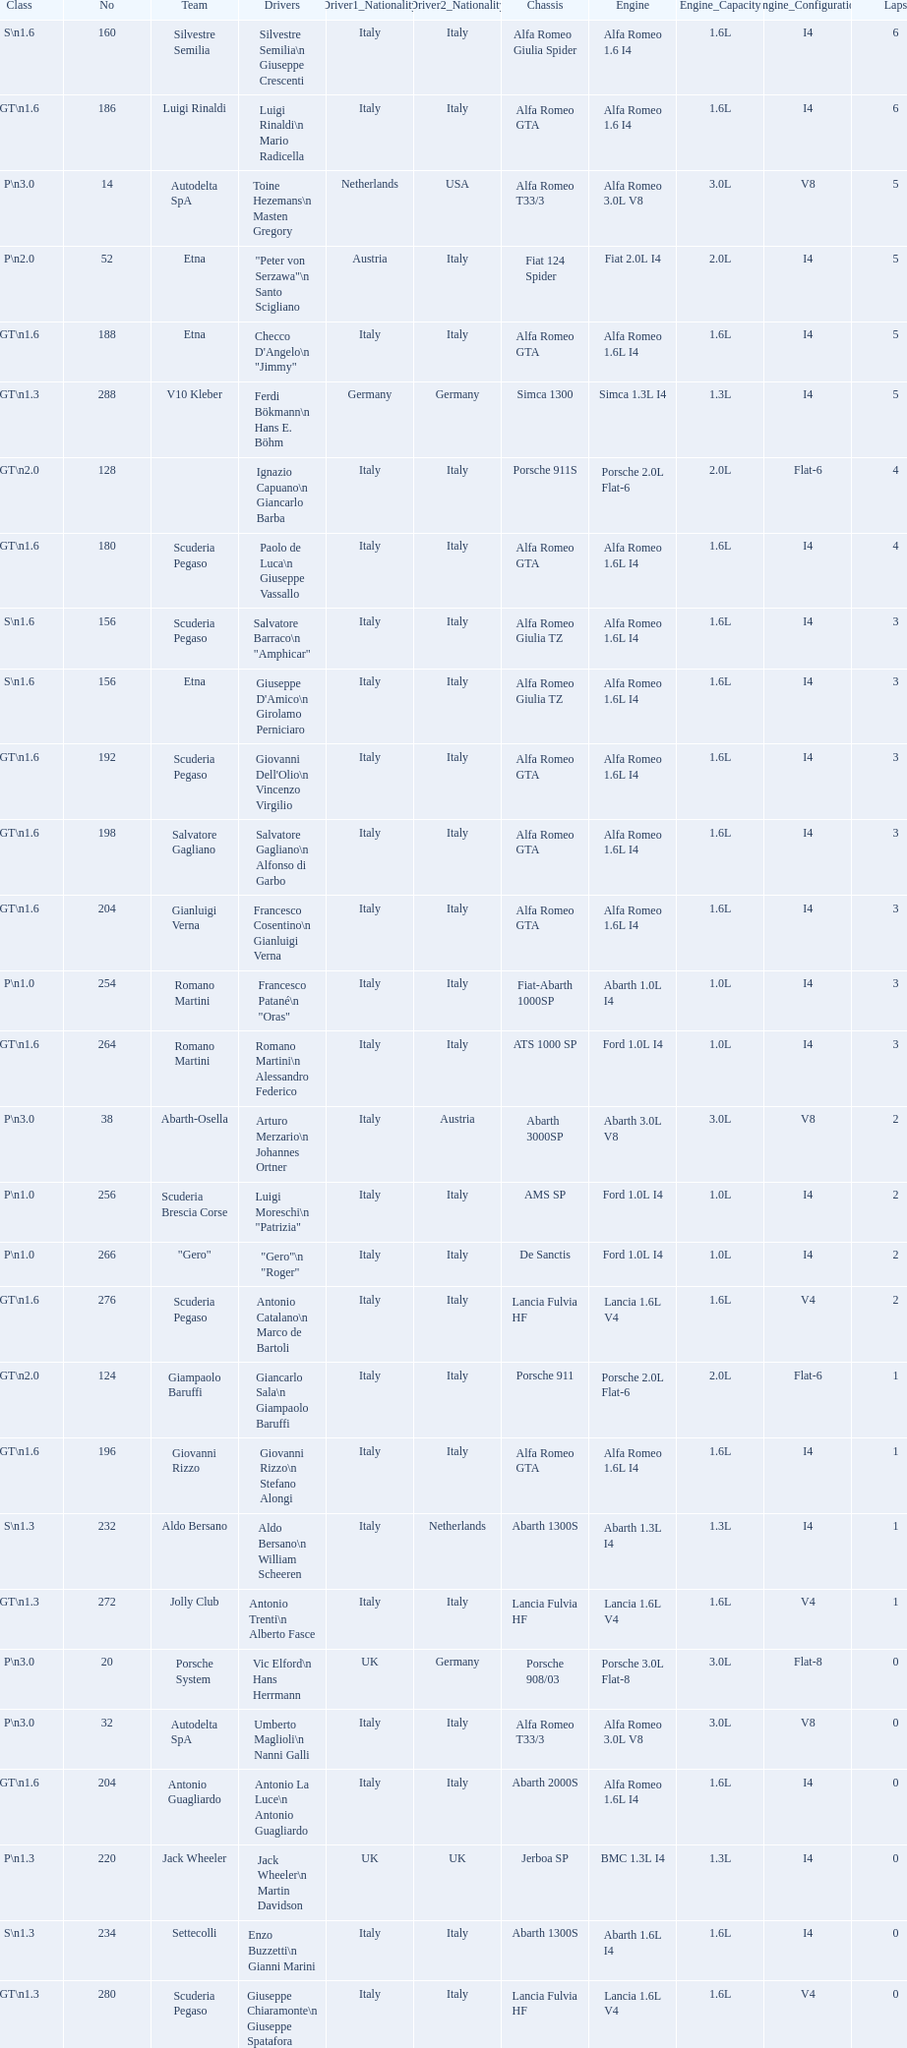How many laps does v10 kleber have? 5. 